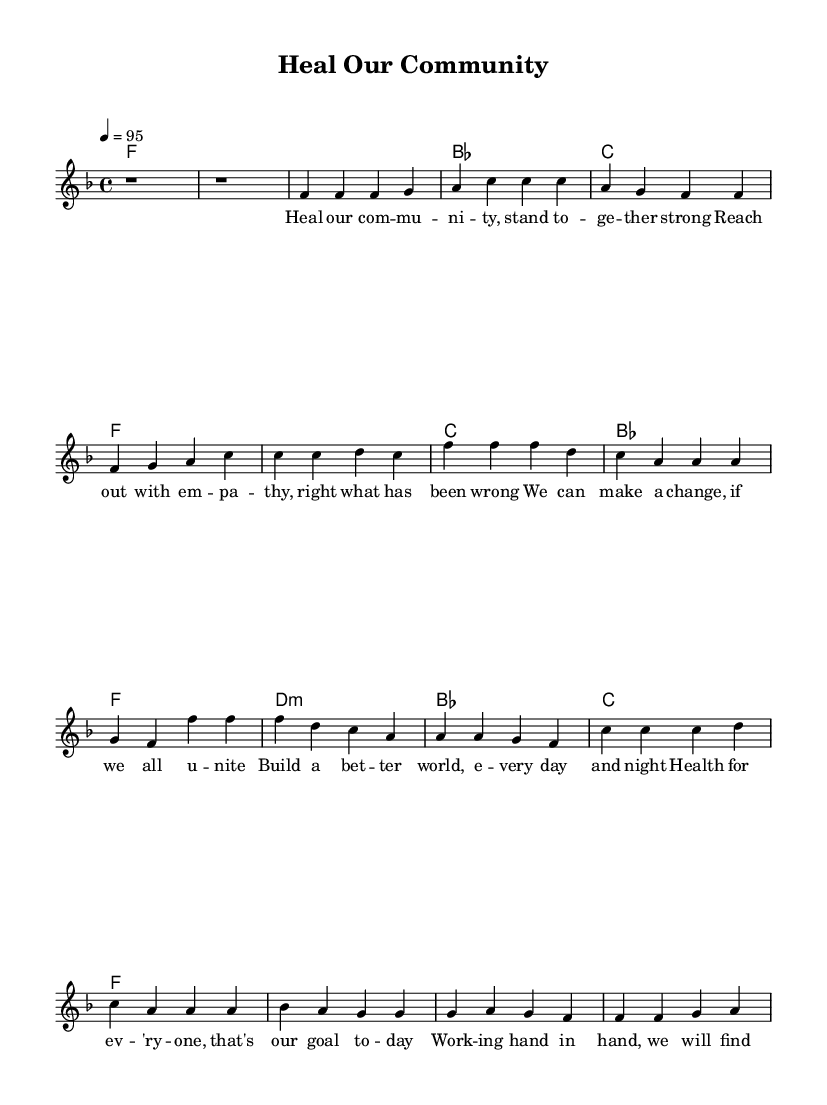What is the key signature of this music? The key signature is F major, which has one flat (B flat). This can be identified from the key signature indicated at the beginning of the score.
Answer: F major What is the time signature of this piece? The time signature is 4/4, which indicates that there are four beats in each measure and the quarter note gets one beat. This is shown at the beginning of the score right after the key signature.
Answer: 4/4 What is the tempo marking of the piece? The tempo marking is 95 beats per minute. This is specified in the tempo indication at the beginning of the score, where it states the number along with the note value.
Answer: 95 How many measures are in the Chorus section? The Chorus section consists of 4 measures, as counted from the music notation under the corresponding lyrics for this section. Each line of melody corresponds to a measure.
Answer: 4 What is the first note of the Bridge section? The first note of the Bridge section is C. This can be determined by looking at the melody line, which starts with a C note when the Bridge begins.
Answer: C What is the lyrical theme of the song? The lyrical theme of the song revolves around community healing and unity for better health. This theme can be derived from analyzing the lyrics provided along with the music, which express the desire for collective action and well-being.
Answer: Community healing What type of chord is used in the first measure of the Bridge? The chord used in the first measure of the Bridge is a D minor chord. This is apparent from the chord notation provided in the harmonic section under the Bridge melody.
Answer: D minor 